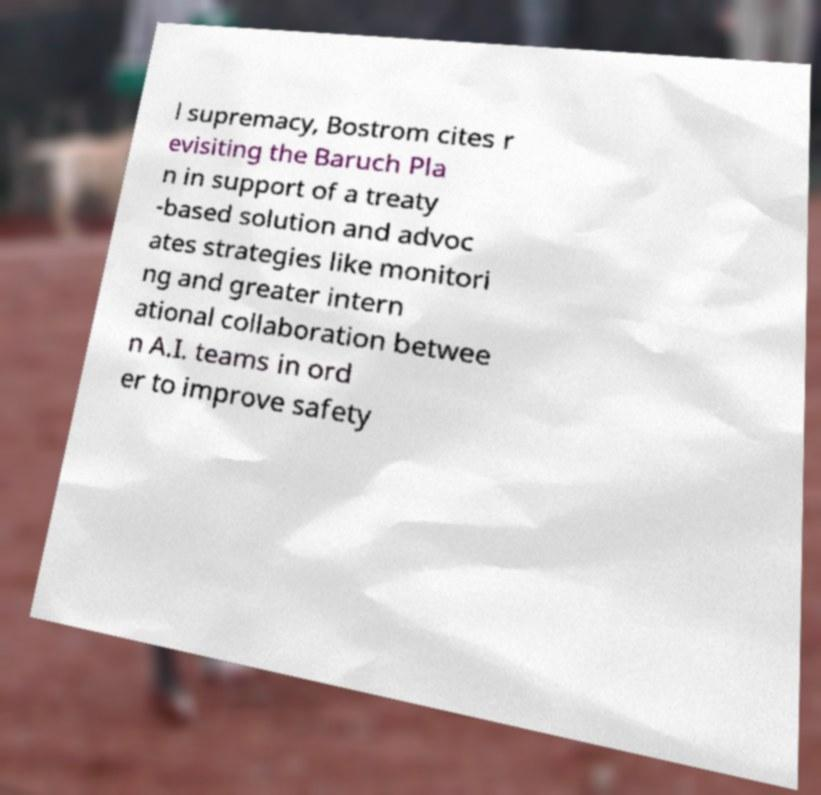There's text embedded in this image that I need extracted. Can you transcribe it verbatim? l supremacy, Bostrom cites r evisiting the Baruch Pla n in support of a treaty -based solution and advoc ates strategies like monitori ng and greater intern ational collaboration betwee n A.I. teams in ord er to improve safety 